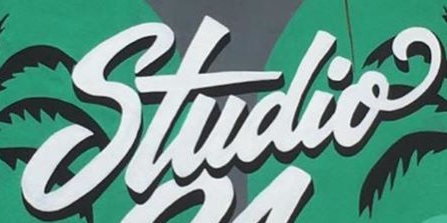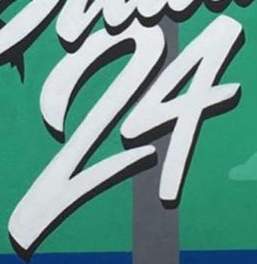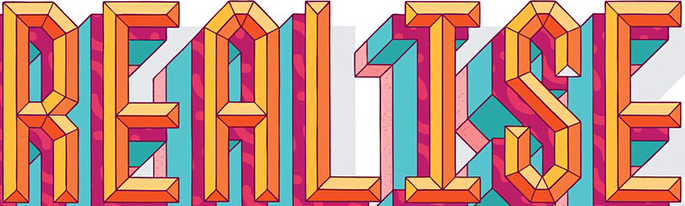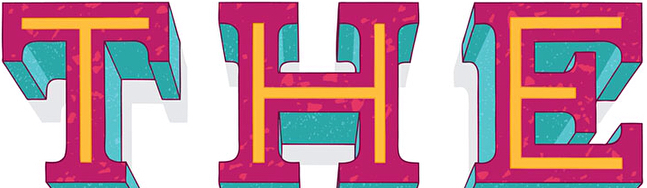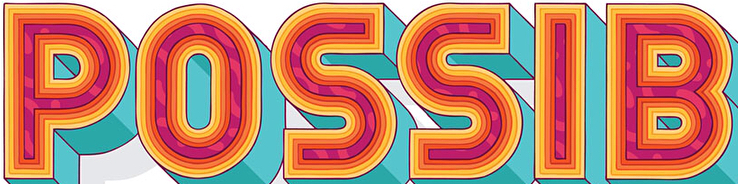What text appears in these images from left to right, separated by a semicolon? Studio; 24; REALISE; THE; POSSIB 